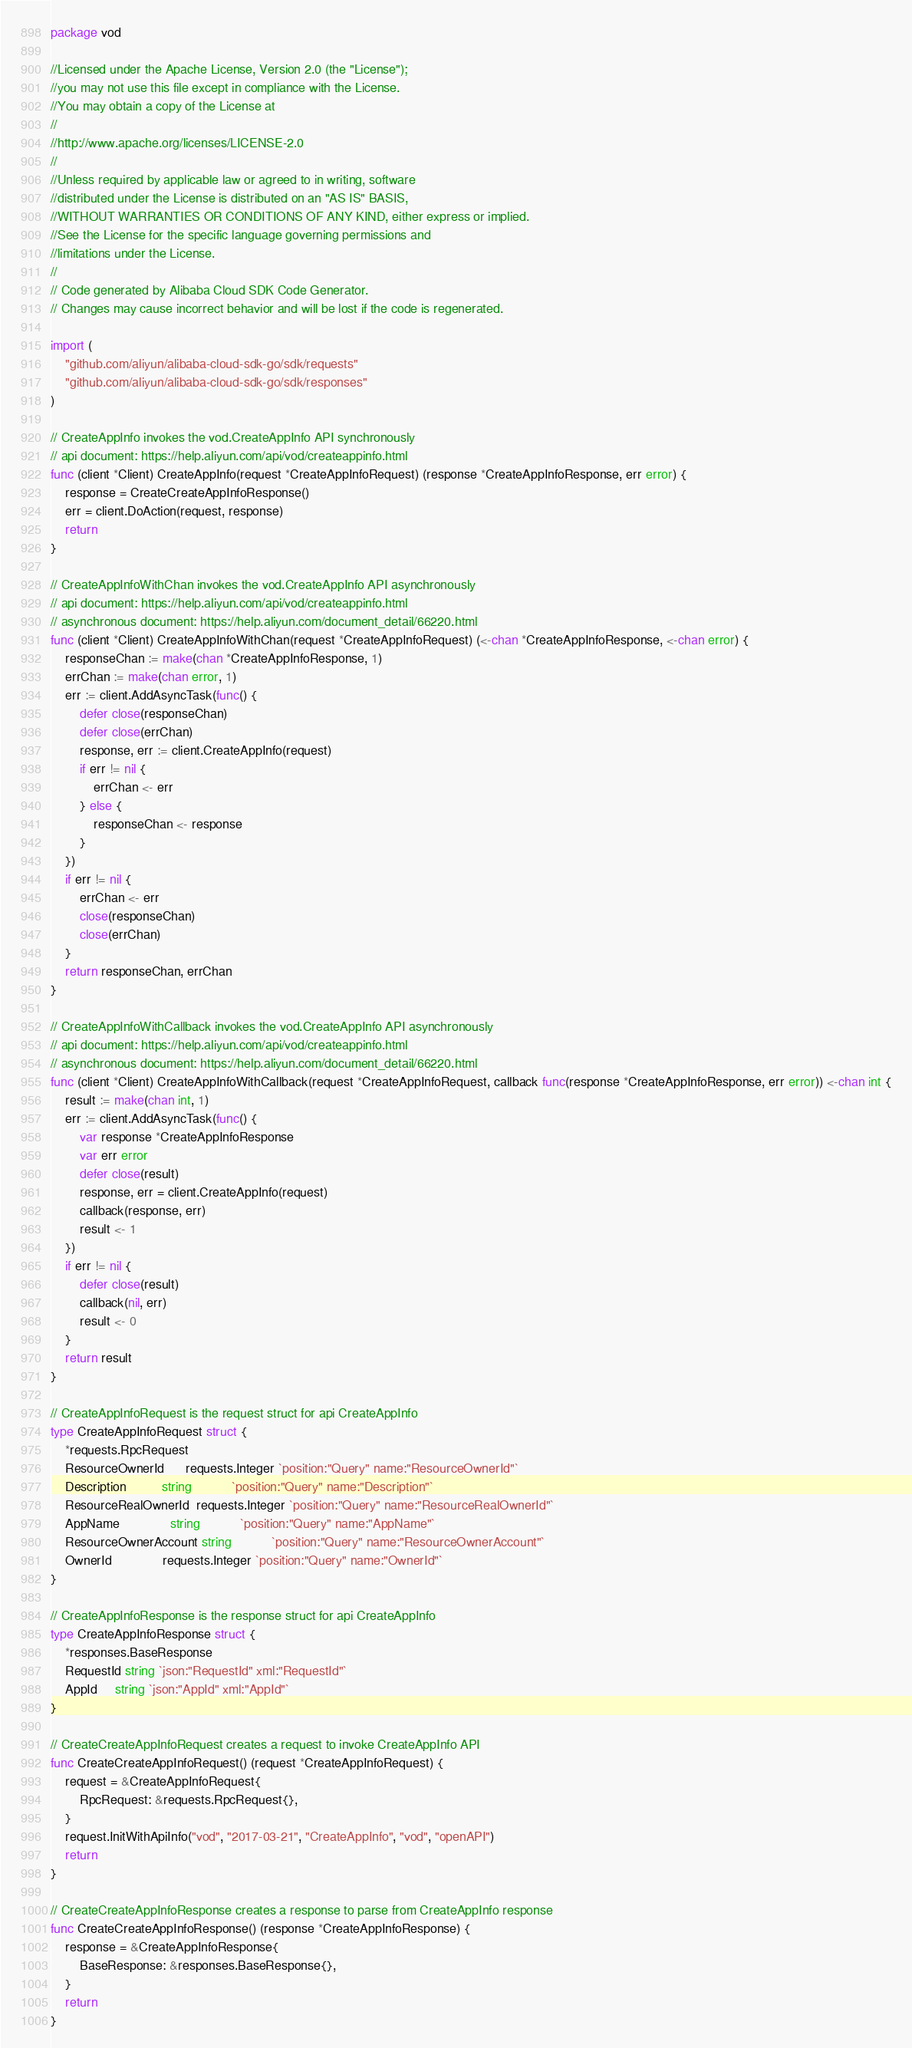Convert code to text. <code><loc_0><loc_0><loc_500><loc_500><_Go_>package vod

//Licensed under the Apache License, Version 2.0 (the "License");
//you may not use this file except in compliance with the License.
//You may obtain a copy of the License at
//
//http://www.apache.org/licenses/LICENSE-2.0
//
//Unless required by applicable law or agreed to in writing, software
//distributed under the License is distributed on an "AS IS" BASIS,
//WITHOUT WARRANTIES OR CONDITIONS OF ANY KIND, either express or implied.
//See the License for the specific language governing permissions and
//limitations under the License.
//
// Code generated by Alibaba Cloud SDK Code Generator.
// Changes may cause incorrect behavior and will be lost if the code is regenerated.

import (
	"github.com/aliyun/alibaba-cloud-sdk-go/sdk/requests"
	"github.com/aliyun/alibaba-cloud-sdk-go/sdk/responses"
)

// CreateAppInfo invokes the vod.CreateAppInfo API synchronously
// api document: https://help.aliyun.com/api/vod/createappinfo.html
func (client *Client) CreateAppInfo(request *CreateAppInfoRequest) (response *CreateAppInfoResponse, err error) {
	response = CreateCreateAppInfoResponse()
	err = client.DoAction(request, response)
	return
}

// CreateAppInfoWithChan invokes the vod.CreateAppInfo API asynchronously
// api document: https://help.aliyun.com/api/vod/createappinfo.html
// asynchronous document: https://help.aliyun.com/document_detail/66220.html
func (client *Client) CreateAppInfoWithChan(request *CreateAppInfoRequest) (<-chan *CreateAppInfoResponse, <-chan error) {
	responseChan := make(chan *CreateAppInfoResponse, 1)
	errChan := make(chan error, 1)
	err := client.AddAsyncTask(func() {
		defer close(responseChan)
		defer close(errChan)
		response, err := client.CreateAppInfo(request)
		if err != nil {
			errChan <- err
		} else {
			responseChan <- response
		}
	})
	if err != nil {
		errChan <- err
		close(responseChan)
		close(errChan)
	}
	return responseChan, errChan
}

// CreateAppInfoWithCallback invokes the vod.CreateAppInfo API asynchronously
// api document: https://help.aliyun.com/api/vod/createappinfo.html
// asynchronous document: https://help.aliyun.com/document_detail/66220.html
func (client *Client) CreateAppInfoWithCallback(request *CreateAppInfoRequest, callback func(response *CreateAppInfoResponse, err error)) <-chan int {
	result := make(chan int, 1)
	err := client.AddAsyncTask(func() {
		var response *CreateAppInfoResponse
		var err error
		defer close(result)
		response, err = client.CreateAppInfo(request)
		callback(response, err)
		result <- 1
	})
	if err != nil {
		defer close(result)
		callback(nil, err)
		result <- 0
	}
	return result
}

// CreateAppInfoRequest is the request struct for api CreateAppInfo
type CreateAppInfoRequest struct {
	*requests.RpcRequest
	ResourceOwnerId      requests.Integer `position:"Query" name:"ResourceOwnerId"`
	Description          string           `position:"Query" name:"Description"`
	ResourceRealOwnerId  requests.Integer `position:"Query" name:"ResourceRealOwnerId"`
	AppName              string           `position:"Query" name:"AppName"`
	ResourceOwnerAccount string           `position:"Query" name:"ResourceOwnerAccount"`
	OwnerId              requests.Integer `position:"Query" name:"OwnerId"`
}

// CreateAppInfoResponse is the response struct for api CreateAppInfo
type CreateAppInfoResponse struct {
	*responses.BaseResponse
	RequestId string `json:"RequestId" xml:"RequestId"`
	AppId     string `json:"AppId" xml:"AppId"`
}

// CreateCreateAppInfoRequest creates a request to invoke CreateAppInfo API
func CreateCreateAppInfoRequest() (request *CreateAppInfoRequest) {
	request = &CreateAppInfoRequest{
		RpcRequest: &requests.RpcRequest{},
	}
	request.InitWithApiInfo("vod", "2017-03-21", "CreateAppInfo", "vod", "openAPI")
	return
}

// CreateCreateAppInfoResponse creates a response to parse from CreateAppInfo response
func CreateCreateAppInfoResponse() (response *CreateAppInfoResponse) {
	response = &CreateAppInfoResponse{
		BaseResponse: &responses.BaseResponse{},
	}
	return
}
</code> 